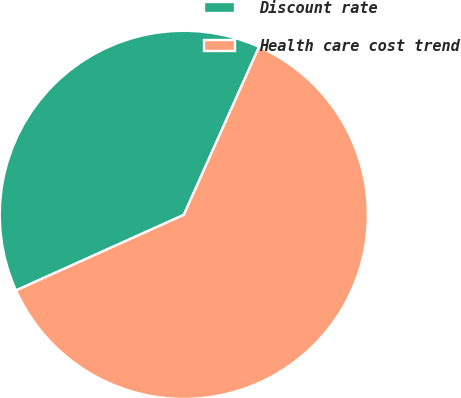Convert chart. <chart><loc_0><loc_0><loc_500><loc_500><pie_chart><fcel>Discount rate<fcel>Health care cost trend<nl><fcel>38.44%<fcel>61.56%<nl></chart> 